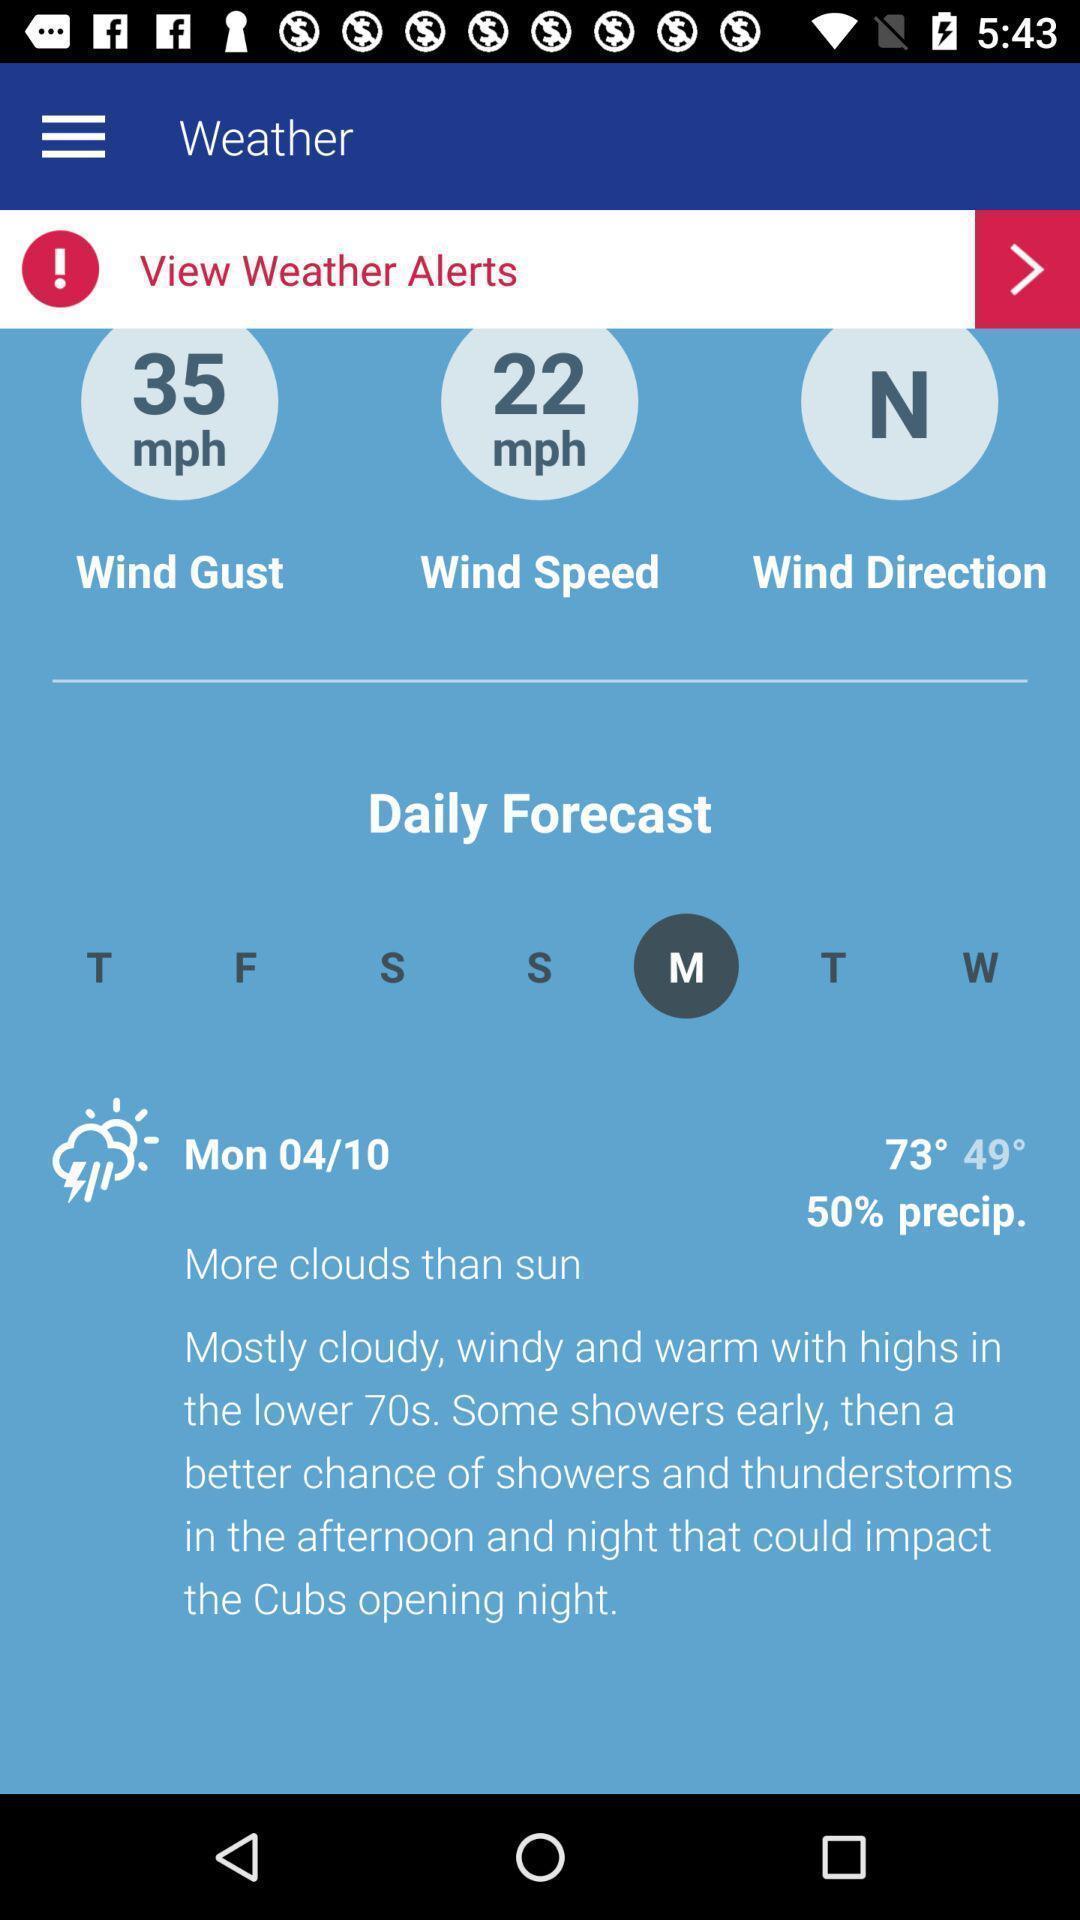Explain what's happening in this screen capture. Screen shows to view weather details. 